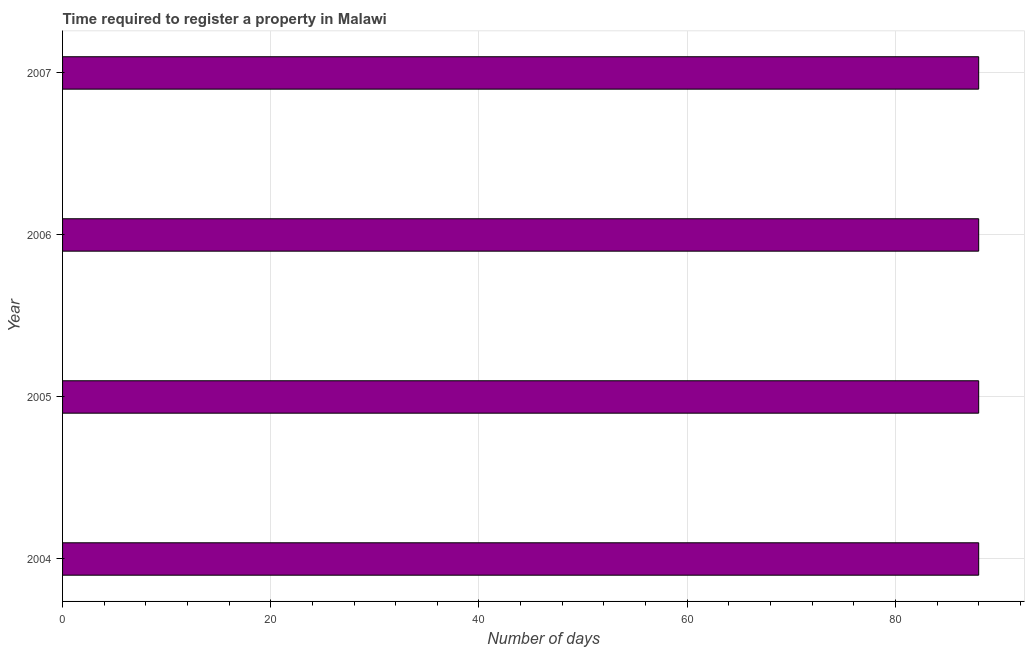What is the title of the graph?
Ensure brevity in your answer.  Time required to register a property in Malawi. What is the label or title of the X-axis?
Ensure brevity in your answer.  Number of days. Across all years, what is the maximum number of days required to register property?
Offer a very short reply. 88. Across all years, what is the minimum number of days required to register property?
Ensure brevity in your answer.  88. In which year was the number of days required to register property minimum?
Your response must be concise. 2004. What is the sum of the number of days required to register property?
Your answer should be compact. 352. What is the average number of days required to register property per year?
Your answer should be compact. 88. Do a majority of the years between 2004 and 2005 (inclusive) have number of days required to register property greater than 88 days?
Keep it short and to the point. No. Is the number of days required to register property in 2005 less than that in 2006?
Your answer should be compact. No. What is the difference between the highest and the second highest number of days required to register property?
Ensure brevity in your answer.  0. In how many years, is the number of days required to register property greater than the average number of days required to register property taken over all years?
Make the answer very short. 0. How many bars are there?
Keep it short and to the point. 4. How many years are there in the graph?
Your response must be concise. 4. What is the difference between two consecutive major ticks on the X-axis?
Your answer should be compact. 20. Are the values on the major ticks of X-axis written in scientific E-notation?
Offer a very short reply. No. What is the Number of days of 2004?
Ensure brevity in your answer.  88. What is the Number of days in 2007?
Provide a succinct answer. 88. What is the difference between the Number of days in 2004 and 2005?
Your answer should be compact. 0. What is the difference between the Number of days in 2004 and 2006?
Provide a short and direct response. 0. What is the difference between the Number of days in 2004 and 2007?
Your answer should be compact. 0. What is the difference between the Number of days in 2005 and 2006?
Offer a very short reply. 0. What is the ratio of the Number of days in 2004 to that in 2005?
Give a very brief answer. 1. What is the ratio of the Number of days in 2004 to that in 2007?
Your answer should be very brief. 1. What is the ratio of the Number of days in 2005 to that in 2006?
Offer a very short reply. 1. What is the ratio of the Number of days in 2005 to that in 2007?
Your answer should be compact. 1. 